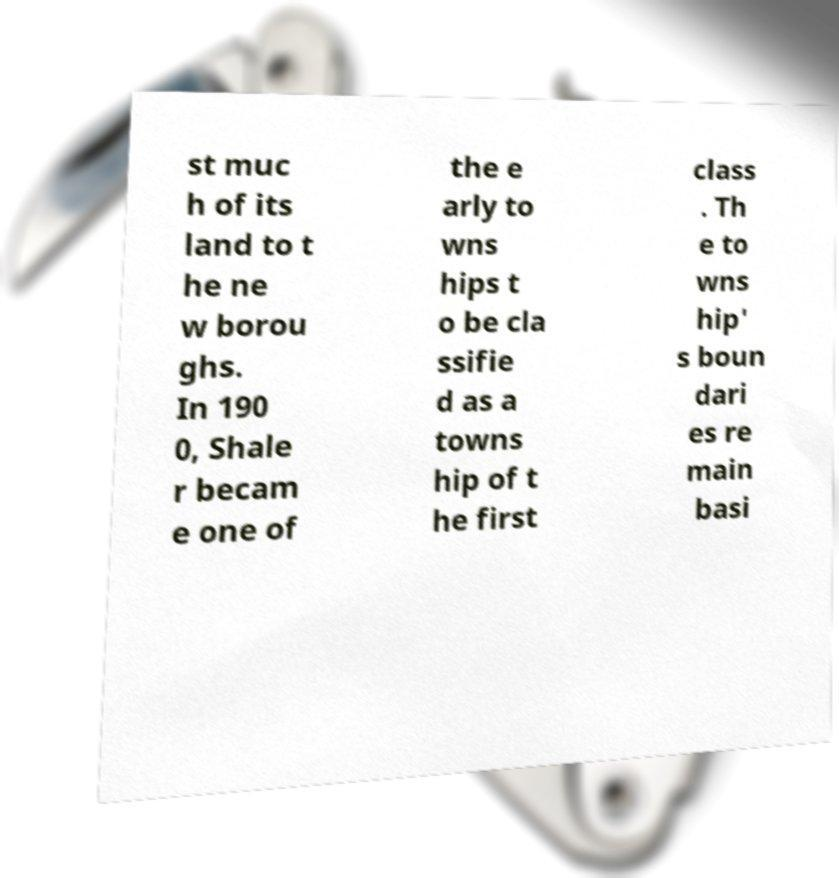I need the written content from this picture converted into text. Can you do that? st muc h of its land to t he ne w borou ghs. In 190 0, Shale r becam e one of the e arly to wns hips t o be cla ssifie d as a towns hip of t he first class . Th e to wns hip' s boun dari es re main basi 